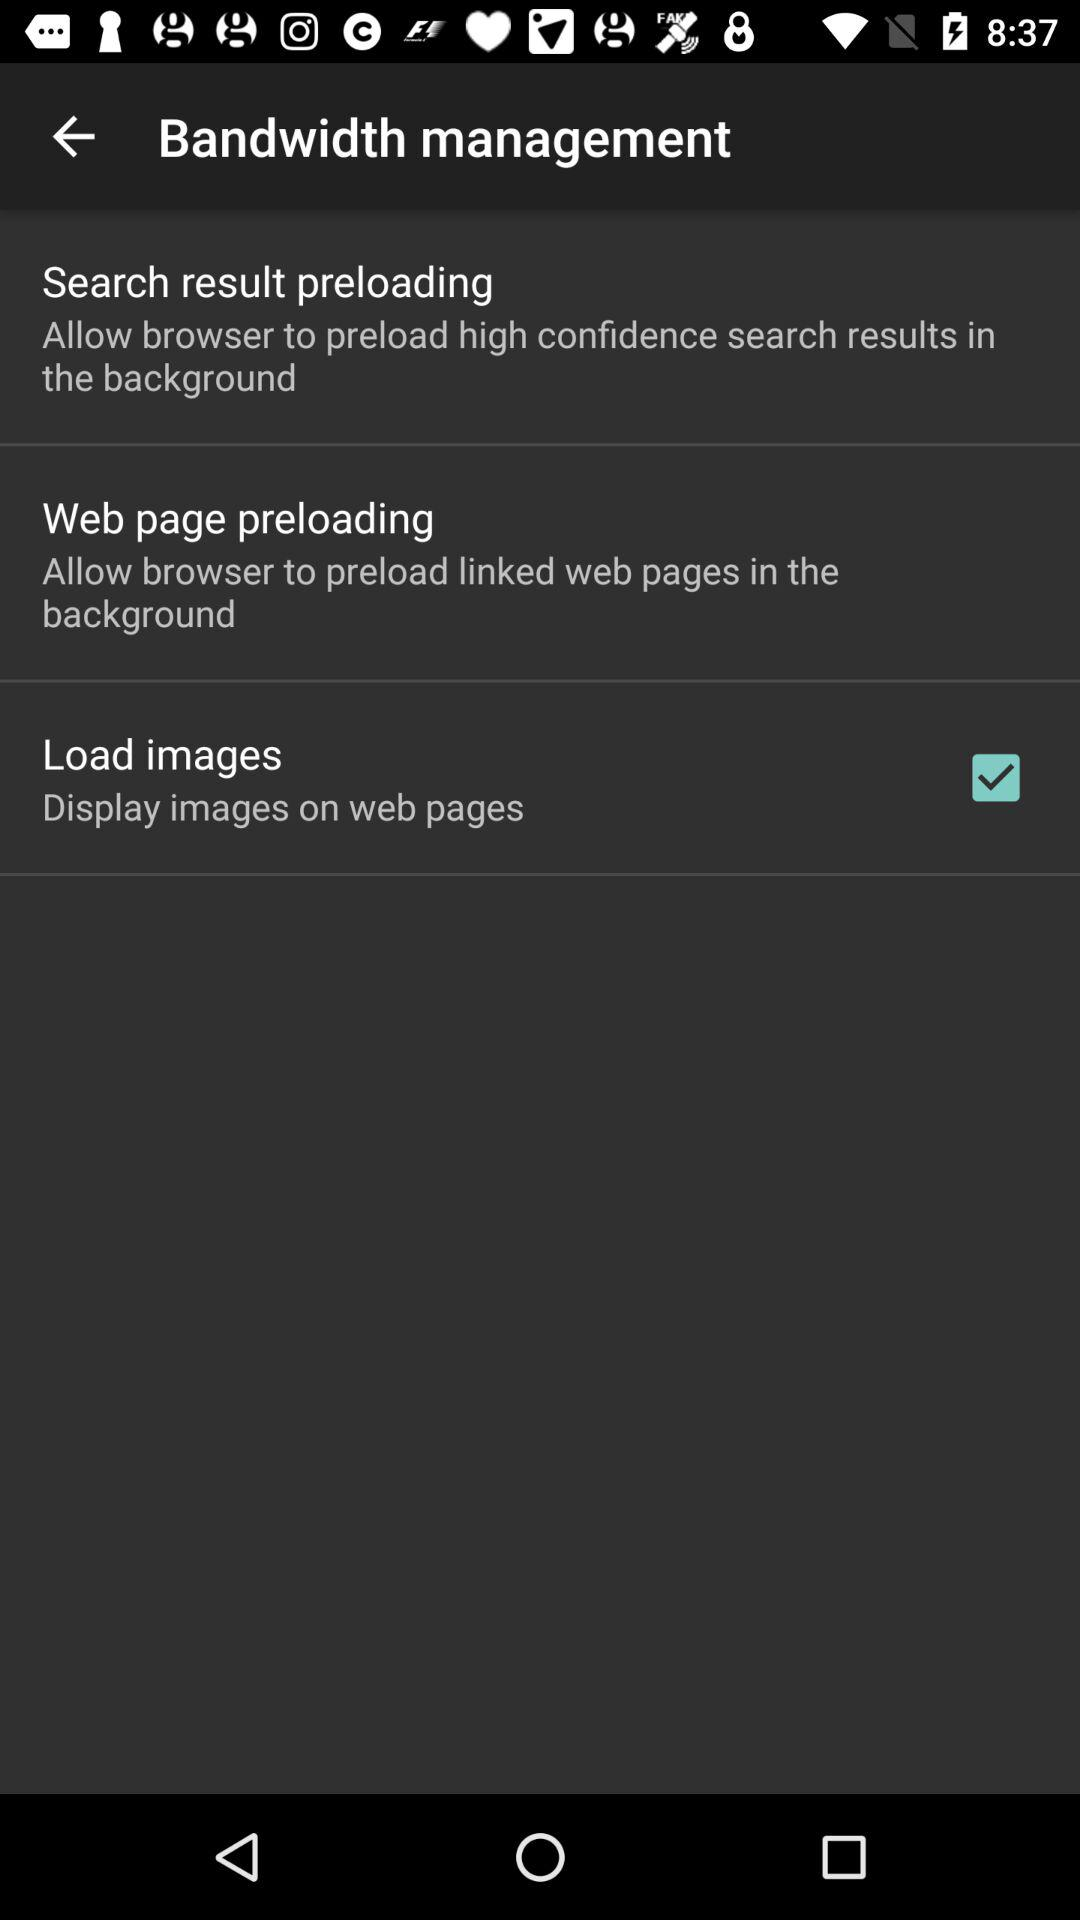How many items are in the bandwidth management section?
Answer the question using a single word or phrase. 3 